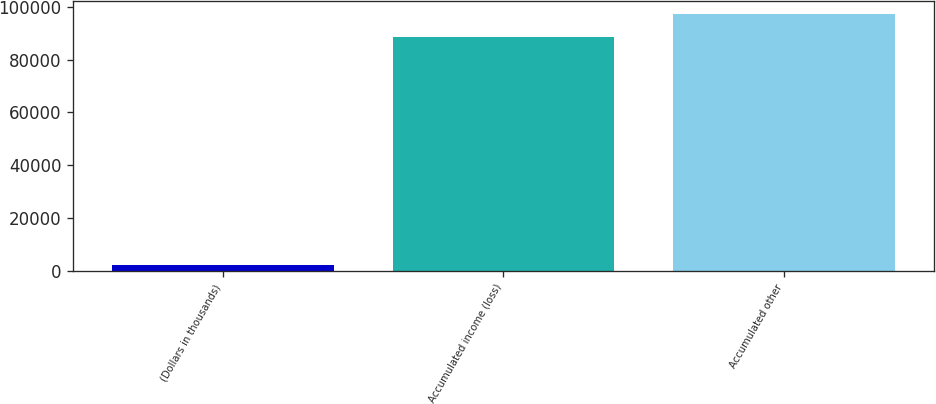Convert chart. <chart><loc_0><loc_0><loc_500><loc_500><bar_chart><fcel>(Dollars in thousands)<fcel>Accumulated income (loss)<fcel>Accumulated other<nl><fcel>2018<fcel>88580<fcel>97236.2<nl></chart> 